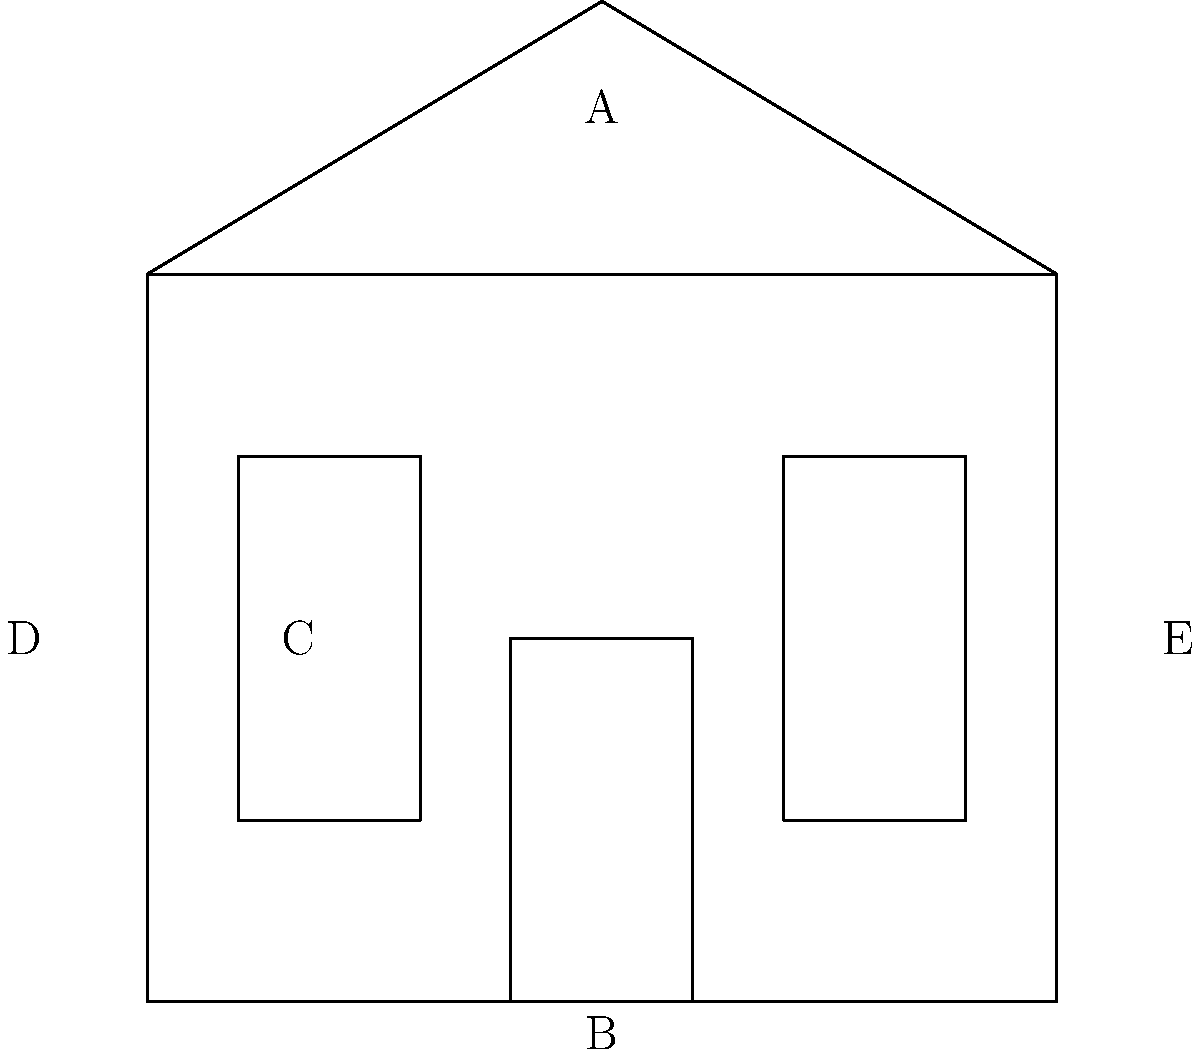Identify the architectural features of this Georgian-style building by matching the labels (A-E) to the correct terms: symmetrical façade, double-hung sash windows, central door, side-gabled roof, and rectangular shape. To correctly identify the architectural features of this Georgian-style building, let's analyze each labeled element:

1. Label A points to the roof. The roof in this diagram is sloped on both sides and comes to a peak in the center, which is characteristic of a side-gabled roof in Georgian architecture.

2. Label B indicates the central door. In Georgian architecture, the main entrance is typically centered on the façade, creating a symmetrical appearance.

3. Label C points to one of the windows. These windows are tall and narrow, divided into two sections (upper and lower), which is typical of double-hung sash windows commonly used in Georgian-style buildings.

4. Label D is pointing to the overall shape of the building. The structure has a clear rectangular form, which is a defining characteristic of Georgian architecture.

5. Label E is not specifically pointing to a feature, but rather to the entire façade. The arrangement of elements - central door with equally spaced windows on either side - demonstrates the symmetrical façade that is a hallmark of Georgian-style buildings.

By matching these observations with the architectural terms provided, we can correctly identify each feature.
Answer: A: Side-gabled roof
B: Central door
C: Double-hung sash windows
D: Rectangular shape
E: Symmetrical façade 